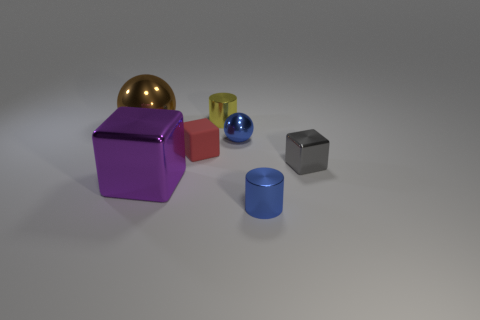Are there any other things that are made of the same material as the red thing?
Offer a terse response. No. Are there fewer tiny gray shiny things that are behind the small yellow metallic cylinder than small red metallic objects?
Your answer should be very brief. No. What material is the red block that is the same size as the blue sphere?
Keep it short and to the point. Rubber. There is a shiny thing that is in front of the small gray metallic thing and on the right side of the small sphere; what is its size?
Ensure brevity in your answer.  Small. There is a purple object that is the same shape as the red rubber object; what size is it?
Offer a terse response. Large. How many objects are large yellow things or cylinders that are behind the tiny metal block?
Ensure brevity in your answer.  1. The yellow thing has what shape?
Offer a very short reply. Cylinder. The big metallic object behind the cube right of the tiny yellow cylinder is what shape?
Provide a short and direct response. Sphere. What is the color of the tiny block that is the same material as the tiny yellow object?
Keep it short and to the point. Gray. There is a shiny cylinder that is in front of the small yellow metal thing; does it have the same color as the ball right of the yellow thing?
Make the answer very short. Yes. 